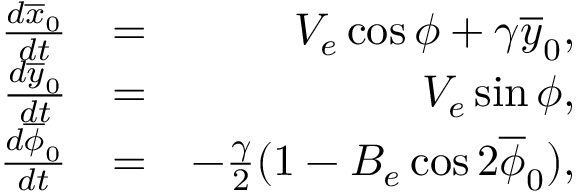<formula> <loc_0><loc_0><loc_500><loc_500>\begin{array} { r l r } { \frac { d \overline { x } _ { 0 } } { d t } } & { = } & { V _ { e } \cos \phi + \gamma \overline { y } _ { 0 } , } \\ { \frac { d \overline { y } _ { 0 } } { d t } } & { = } & { V _ { e } \sin \phi , } \\ { \frac { d \overline { \phi } _ { 0 } } { d t } } & { = } & { - \frac { \gamma } { 2 } ( 1 - B _ { e } \cos 2 \overline { \phi } _ { 0 } ) , } \end{array}</formula> 